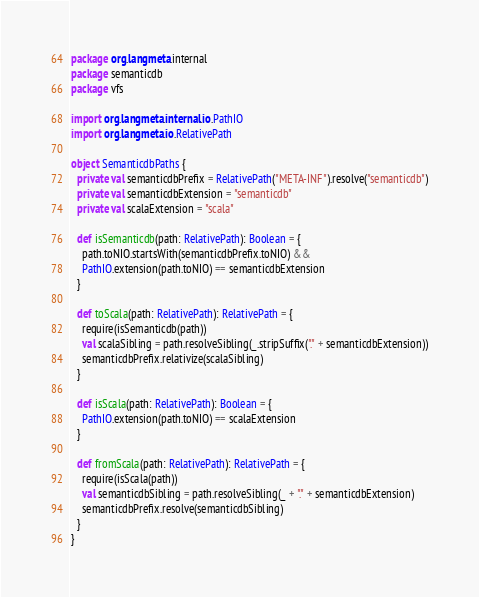<code> <loc_0><loc_0><loc_500><loc_500><_Scala_>package org.langmeta.internal
package semanticdb
package vfs

import org.langmeta.internal.io.PathIO
import org.langmeta.io.RelativePath

object SemanticdbPaths {
  private val semanticdbPrefix = RelativePath("META-INF").resolve("semanticdb")
  private val semanticdbExtension = "semanticdb"
  private val scalaExtension = "scala"

  def isSemanticdb(path: RelativePath): Boolean = {
    path.toNIO.startsWith(semanticdbPrefix.toNIO) &&
    PathIO.extension(path.toNIO) == semanticdbExtension
  }

  def toScala(path: RelativePath): RelativePath = {
    require(isSemanticdb(path))
    val scalaSibling = path.resolveSibling(_.stripSuffix("." + semanticdbExtension))
    semanticdbPrefix.relativize(scalaSibling)
  }

  def isScala(path: RelativePath): Boolean = {
    PathIO.extension(path.toNIO) == scalaExtension
  }

  def fromScala(path: RelativePath): RelativePath = {
    require(isScala(path))
    val semanticdbSibling = path.resolveSibling(_ + "." + semanticdbExtension)
    semanticdbPrefix.resolve(semanticdbSibling)
  }
}
</code> 